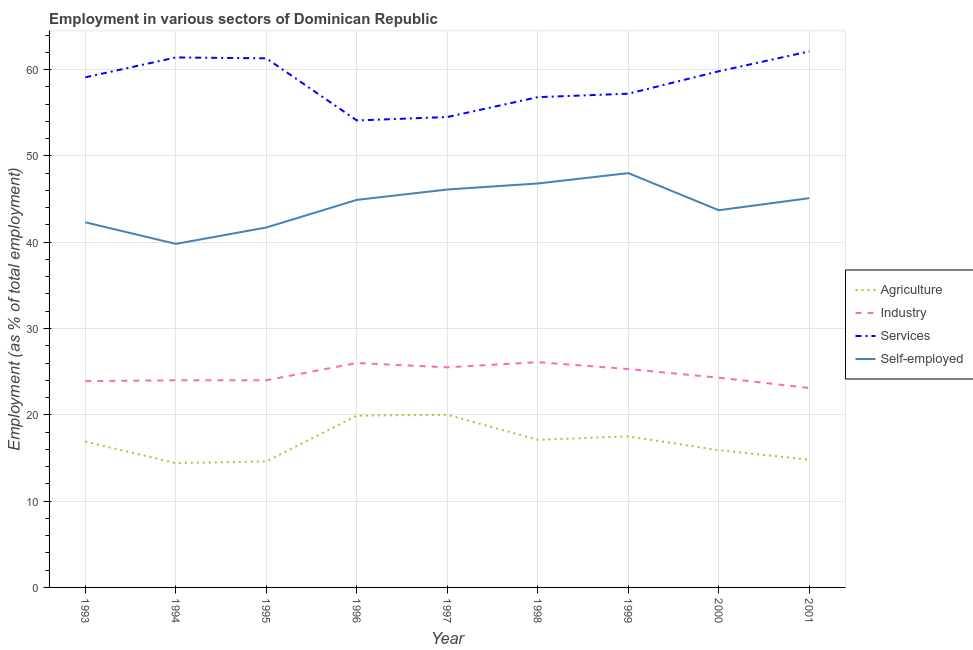Is the number of lines equal to the number of legend labels?
Your answer should be compact. Yes. What is the percentage of workers in services in 1998?
Offer a very short reply. 56.8. Across all years, what is the minimum percentage of workers in services?
Your answer should be very brief. 54.1. In which year was the percentage of workers in agriculture maximum?
Ensure brevity in your answer.  1997. What is the total percentage of workers in services in the graph?
Give a very brief answer. 526.3. What is the difference between the percentage of workers in services in 1994 and that in 2001?
Offer a very short reply. -0.7. What is the difference between the percentage of workers in industry in 2000 and the percentage of workers in services in 2001?
Keep it short and to the point. -37.8. What is the average percentage of workers in industry per year?
Offer a terse response. 24.69. In the year 1996, what is the difference between the percentage of workers in services and percentage of workers in industry?
Ensure brevity in your answer.  28.1. In how many years, is the percentage of workers in industry greater than 38 %?
Your answer should be very brief. 0. What is the ratio of the percentage of workers in agriculture in 1993 to that in 2001?
Provide a succinct answer. 1.14. Is the percentage of self employed workers in 1993 less than that in 1998?
Make the answer very short. Yes. Is the difference between the percentage of workers in services in 1993 and 1999 greater than the difference between the percentage of workers in agriculture in 1993 and 1999?
Ensure brevity in your answer.  Yes. What is the difference between the highest and the second highest percentage of workers in industry?
Keep it short and to the point. 0.1. What is the difference between the highest and the lowest percentage of self employed workers?
Offer a very short reply. 8.2. Is the sum of the percentage of workers in industry in 1998 and 1999 greater than the maximum percentage of self employed workers across all years?
Make the answer very short. Yes. Is it the case that in every year, the sum of the percentage of workers in agriculture and percentage of workers in industry is greater than the percentage of workers in services?
Make the answer very short. No. Is the percentage of workers in industry strictly less than the percentage of self employed workers over the years?
Make the answer very short. Yes. Are the values on the major ticks of Y-axis written in scientific E-notation?
Provide a succinct answer. No. Does the graph contain grids?
Keep it short and to the point. Yes. How many legend labels are there?
Offer a very short reply. 4. How are the legend labels stacked?
Your answer should be very brief. Vertical. What is the title of the graph?
Provide a short and direct response. Employment in various sectors of Dominican Republic. Does "Primary" appear as one of the legend labels in the graph?
Your response must be concise. No. What is the label or title of the Y-axis?
Provide a short and direct response. Employment (as % of total employment). What is the Employment (as % of total employment) of Agriculture in 1993?
Your answer should be very brief. 16.9. What is the Employment (as % of total employment) in Industry in 1993?
Give a very brief answer. 23.9. What is the Employment (as % of total employment) of Services in 1993?
Provide a succinct answer. 59.1. What is the Employment (as % of total employment) of Self-employed in 1993?
Keep it short and to the point. 42.3. What is the Employment (as % of total employment) of Agriculture in 1994?
Your answer should be very brief. 14.4. What is the Employment (as % of total employment) of Services in 1994?
Make the answer very short. 61.4. What is the Employment (as % of total employment) in Self-employed in 1994?
Give a very brief answer. 39.8. What is the Employment (as % of total employment) in Agriculture in 1995?
Offer a terse response. 14.6. What is the Employment (as % of total employment) of Industry in 1995?
Give a very brief answer. 24. What is the Employment (as % of total employment) in Services in 1995?
Your answer should be compact. 61.3. What is the Employment (as % of total employment) in Self-employed in 1995?
Offer a very short reply. 41.7. What is the Employment (as % of total employment) in Agriculture in 1996?
Make the answer very short. 19.9. What is the Employment (as % of total employment) of Services in 1996?
Provide a succinct answer. 54.1. What is the Employment (as % of total employment) of Self-employed in 1996?
Make the answer very short. 44.9. What is the Employment (as % of total employment) of Services in 1997?
Make the answer very short. 54.5. What is the Employment (as % of total employment) in Self-employed in 1997?
Provide a succinct answer. 46.1. What is the Employment (as % of total employment) of Agriculture in 1998?
Offer a very short reply. 17.1. What is the Employment (as % of total employment) in Industry in 1998?
Make the answer very short. 26.1. What is the Employment (as % of total employment) of Services in 1998?
Your answer should be very brief. 56.8. What is the Employment (as % of total employment) in Self-employed in 1998?
Offer a very short reply. 46.8. What is the Employment (as % of total employment) in Agriculture in 1999?
Your answer should be compact. 17.5. What is the Employment (as % of total employment) in Industry in 1999?
Offer a terse response. 25.3. What is the Employment (as % of total employment) in Services in 1999?
Your answer should be compact. 57.2. What is the Employment (as % of total employment) of Agriculture in 2000?
Keep it short and to the point. 15.9. What is the Employment (as % of total employment) of Industry in 2000?
Offer a terse response. 24.3. What is the Employment (as % of total employment) of Services in 2000?
Give a very brief answer. 59.8. What is the Employment (as % of total employment) in Self-employed in 2000?
Your answer should be compact. 43.7. What is the Employment (as % of total employment) of Agriculture in 2001?
Your answer should be compact. 14.8. What is the Employment (as % of total employment) of Industry in 2001?
Offer a very short reply. 23.1. What is the Employment (as % of total employment) of Services in 2001?
Provide a succinct answer. 62.1. What is the Employment (as % of total employment) in Self-employed in 2001?
Offer a terse response. 45.1. Across all years, what is the maximum Employment (as % of total employment) of Industry?
Keep it short and to the point. 26.1. Across all years, what is the maximum Employment (as % of total employment) in Services?
Offer a terse response. 62.1. Across all years, what is the minimum Employment (as % of total employment) of Agriculture?
Provide a short and direct response. 14.4. Across all years, what is the minimum Employment (as % of total employment) in Industry?
Give a very brief answer. 23.1. Across all years, what is the minimum Employment (as % of total employment) in Services?
Your answer should be compact. 54.1. Across all years, what is the minimum Employment (as % of total employment) of Self-employed?
Keep it short and to the point. 39.8. What is the total Employment (as % of total employment) in Agriculture in the graph?
Provide a short and direct response. 151.1. What is the total Employment (as % of total employment) of Industry in the graph?
Make the answer very short. 222.2. What is the total Employment (as % of total employment) in Services in the graph?
Offer a terse response. 526.3. What is the total Employment (as % of total employment) of Self-employed in the graph?
Give a very brief answer. 398.4. What is the difference between the Employment (as % of total employment) of Agriculture in 1993 and that in 1994?
Give a very brief answer. 2.5. What is the difference between the Employment (as % of total employment) of Agriculture in 1993 and that in 1995?
Provide a short and direct response. 2.3. What is the difference between the Employment (as % of total employment) of Industry in 1993 and that in 1995?
Keep it short and to the point. -0.1. What is the difference between the Employment (as % of total employment) in Agriculture in 1993 and that in 1996?
Your response must be concise. -3. What is the difference between the Employment (as % of total employment) in Industry in 1993 and that in 1996?
Keep it short and to the point. -2.1. What is the difference between the Employment (as % of total employment) of Agriculture in 1993 and that in 1997?
Give a very brief answer. -3.1. What is the difference between the Employment (as % of total employment) in Industry in 1993 and that in 1997?
Provide a succinct answer. -1.6. What is the difference between the Employment (as % of total employment) of Services in 1993 and that in 1997?
Keep it short and to the point. 4.6. What is the difference between the Employment (as % of total employment) in Industry in 1993 and that in 1998?
Keep it short and to the point. -2.2. What is the difference between the Employment (as % of total employment) of Self-employed in 1993 and that in 1998?
Offer a terse response. -4.5. What is the difference between the Employment (as % of total employment) in Agriculture in 1993 and that in 1999?
Ensure brevity in your answer.  -0.6. What is the difference between the Employment (as % of total employment) of Industry in 1993 and that in 1999?
Your answer should be very brief. -1.4. What is the difference between the Employment (as % of total employment) in Services in 1993 and that in 1999?
Ensure brevity in your answer.  1.9. What is the difference between the Employment (as % of total employment) of Agriculture in 1993 and that in 2001?
Provide a short and direct response. 2.1. What is the difference between the Employment (as % of total employment) of Agriculture in 1994 and that in 1995?
Provide a succinct answer. -0.2. What is the difference between the Employment (as % of total employment) in Industry in 1994 and that in 1995?
Offer a terse response. 0. What is the difference between the Employment (as % of total employment) in Self-employed in 1994 and that in 1995?
Your answer should be compact. -1.9. What is the difference between the Employment (as % of total employment) of Industry in 1994 and that in 1996?
Offer a very short reply. -2. What is the difference between the Employment (as % of total employment) in Services in 1994 and that in 1996?
Provide a succinct answer. 7.3. What is the difference between the Employment (as % of total employment) in Agriculture in 1994 and that in 1997?
Make the answer very short. -5.6. What is the difference between the Employment (as % of total employment) of Services in 1994 and that in 1997?
Give a very brief answer. 6.9. What is the difference between the Employment (as % of total employment) of Agriculture in 1994 and that in 1998?
Keep it short and to the point. -2.7. What is the difference between the Employment (as % of total employment) in Services in 1994 and that in 1998?
Offer a very short reply. 4.6. What is the difference between the Employment (as % of total employment) of Agriculture in 1994 and that in 1999?
Offer a terse response. -3.1. What is the difference between the Employment (as % of total employment) in Services in 1994 and that in 1999?
Offer a terse response. 4.2. What is the difference between the Employment (as % of total employment) in Self-employed in 1994 and that in 1999?
Your answer should be very brief. -8.2. What is the difference between the Employment (as % of total employment) in Agriculture in 1994 and that in 2000?
Ensure brevity in your answer.  -1.5. What is the difference between the Employment (as % of total employment) in Industry in 1994 and that in 2000?
Offer a terse response. -0.3. What is the difference between the Employment (as % of total employment) in Industry in 1994 and that in 2001?
Provide a short and direct response. 0.9. What is the difference between the Employment (as % of total employment) of Services in 1994 and that in 2001?
Provide a short and direct response. -0.7. What is the difference between the Employment (as % of total employment) in Industry in 1995 and that in 1996?
Make the answer very short. -2. What is the difference between the Employment (as % of total employment) in Agriculture in 1995 and that in 1998?
Provide a short and direct response. -2.5. What is the difference between the Employment (as % of total employment) of Self-employed in 1995 and that in 1998?
Give a very brief answer. -5.1. What is the difference between the Employment (as % of total employment) of Agriculture in 1995 and that in 1999?
Your answer should be very brief. -2.9. What is the difference between the Employment (as % of total employment) in Industry in 1995 and that in 1999?
Give a very brief answer. -1.3. What is the difference between the Employment (as % of total employment) of Services in 1995 and that in 1999?
Provide a succinct answer. 4.1. What is the difference between the Employment (as % of total employment) of Industry in 1995 and that in 2000?
Provide a succinct answer. -0.3. What is the difference between the Employment (as % of total employment) in Services in 1995 and that in 2000?
Your response must be concise. 1.5. What is the difference between the Employment (as % of total employment) of Self-employed in 1995 and that in 2000?
Your answer should be compact. -2. What is the difference between the Employment (as % of total employment) in Agriculture in 1995 and that in 2001?
Provide a short and direct response. -0.2. What is the difference between the Employment (as % of total employment) of Industry in 1995 and that in 2001?
Ensure brevity in your answer.  0.9. What is the difference between the Employment (as % of total employment) of Agriculture in 1996 and that in 1997?
Make the answer very short. -0.1. What is the difference between the Employment (as % of total employment) in Industry in 1996 and that in 1997?
Give a very brief answer. 0.5. What is the difference between the Employment (as % of total employment) in Agriculture in 1996 and that in 1998?
Offer a terse response. 2.8. What is the difference between the Employment (as % of total employment) of Industry in 1996 and that in 1998?
Make the answer very short. -0.1. What is the difference between the Employment (as % of total employment) of Agriculture in 1996 and that in 1999?
Offer a very short reply. 2.4. What is the difference between the Employment (as % of total employment) in Industry in 1996 and that in 1999?
Offer a very short reply. 0.7. What is the difference between the Employment (as % of total employment) of Agriculture in 1996 and that in 2000?
Your answer should be compact. 4. What is the difference between the Employment (as % of total employment) in Services in 1996 and that in 2000?
Make the answer very short. -5.7. What is the difference between the Employment (as % of total employment) in Services in 1997 and that in 1998?
Your response must be concise. -2.3. What is the difference between the Employment (as % of total employment) in Industry in 1997 and that in 1999?
Offer a very short reply. 0.2. What is the difference between the Employment (as % of total employment) in Services in 1997 and that in 1999?
Offer a very short reply. -2.7. What is the difference between the Employment (as % of total employment) in Self-employed in 1997 and that in 1999?
Your answer should be very brief. -1.9. What is the difference between the Employment (as % of total employment) of Agriculture in 1997 and that in 2000?
Make the answer very short. 4.1. What is the difference between the Employment (as % of total employment) of Agriculture in 1997 and that in 2001?
Ensure brevity in your answer.  5.2. What is the difference between the Employment (as % of total employment) in Services in 1997 and that in 2001?
Provide a succinct answer. -7.6. What is the difference between the Employment (as % of total employment) of Self-employed in 1997 and that in 2001?
Provide a succinct answer. 1. What is the difference between the Employment (as % of total employment) of Agriculture in 1998 and that in 1999?
Make the answer very short. -0.4. What is the difference between the Employment (as % of total employment) in Agriculture in 1998 and that in 2000?
Keep it short and to the point. 1.2. What is the difference between the Employment (as % of total employment) of Industry in 1998 and that in 2000?
Your response must be concise. 1.8. What is the difference between the Employment (as % of total employment) in Self-employed in 1998 and that in 2000?
Offer a terse response. 3.1. What is the difference between the Employment (as % of total employment) of Agriculture in 1998 and that in 2001?
Your answer should be very brief. 2.3. What is the difference between the Employment (as % of total employment) in Self-employed in 1999 and that in 2000?
Your answer should be very brief. 4.3. What is the difference between the Employment (as % of total employment) in Services in 1999 and that in 2001?
Offer a terse response. -4.9. What is the difference between the Employment (as % of total employment) in Industry in 2000 and that in 2001?
Offer a terse response. 1.2. What is the difference between the Employment (as % of total employment) of Self-employed in 2000 and that in 2001?
Offer a terse response. -1.4. What is the difference between the Employment (as % of total employment) of Agriculture in 1993 and the Employment (as % of total employment) of Services in 1994?
Offer a terse response. -44.5. What is the difference between the Employment (as % of total employment) in Agriculture in 1993 and the Employment (as % of total employment) in Self-employed in 1994?
Give a very brief answer. -22.9. What is the difference between the Employment (as % of total employment) of Industry in 1993 and the Employment (as % of total employment) of Services in 1994?
Offer a very short reply. -37.5. What is the difference between the Employment (as % of total employment) of Industry in 1993 and the Employment (as % of total employment) of Self-employed in 1994?
Your answer should be very brief. -15.9. What is the difference between the Employment (as % of total employment) of Services in 1993 and the Employment (as % of total employment) of Self-employed in 1994?
Make the answer very short. 19.3. What is the difference between the Employment (as % of total employment) of Agriculture in 1993 and the Employment (as % of total employment) of Industry in 1995?
Ensure brevity in your answer.  -7.1. What is the difference between the Employment (as % of total employment) of Agriculture in 1993 and the Employment (as % of total employment) of Services in 1995?
Your answer should be very brief. -44.4. What is the difference between the Employment (as % of total employment) in Agriculture in 1993 and the Employment (as % of total employment) in Self-employed in 1995?
Make the answer very short. -24.8. What is the difference between the Employment (as % of total employment) in Industry in 1993 and the Employment (as % of total employment) in Services in 1995?
Ensure brevity in your answer.  -37.4. What is the difference between the Employment (as % of total employment) in Industry in 1993 and the Employment (as % of total employment) in Self-employed in 1995?
Ensure brevity in your answer.  -17.8. What is the difference between the Employment (as % of total employment) in Agriculture in 1993 and the Employment (as % of total employment) in Services in 1996?
Your answer should be compact. -37.2. What is the difference between the Employment (as % of total employment) of Industry in 1993 and the Employment (as % of total employment) of Services in 1996?
Give a very brief answer. -30.2. What is the difference between the Employment (as % of total employment) in Services in 1993 and the Employment (as % of total employment) in Self-employed in 1996?
Ensure brevity in your answer.  14.2. What is the difference between the Employment (as % of total employment) of Agriculture in 1993 and the Employment (as % of total employment) of Industry in 1997?
Give a very brief answer. -8.6. What is the difference between the Employment (as % of total employment) of Agriculture in 1993 and the Employment (as % of total employment) of Services in 1997?
Provide a succinct answer. -37.6. What is the difference between the Employment (as % of total employment) of Agriculture in 1993 and the Employment (as % of total employment) of Self-employed in 1997?
Keep it short and to the point. -29.2. What is the difference between the Employment (as % of total employment) of Industry in 1993 and the Employment (as % of total employment) of Services in 1997?
Ensure brevity in your answer.  -30.6. What is the difference between the Employment (as % of total employment) of Industry in 1993 and the Employment (as % of total employment) of Self-employed in 1997?
Ensure brevity in your answer.  -22.2. What is the difference between the Employment (as % of total employment) in Services in 1993 and the Employment (as % of total employment) in Self-employed in 1997?
Provide a succinct answer. 13. What is the difference between the Employment (as % of total employment) in Agriculture in 1993 and the Employment (as % of total employment) in Services in 1998?
Offer a terse response. -39.9. What is the difference between the Employment (as % of total employment) in Agriculture in 1993 and the Employment (as % of total employment) in Self-employed in 1998?
Your response must be concise. -29.9. What is the difference between the Employment (as % of total employment) of Industry in 1993 and the Employment (as % of total employment) of Services in 1998?
Offer a terse response. -32.9. What is the difference between the Employment (as % of total employment) of Industry in 1993 and the Employment (as % of total employment) of Self-employed in 1998?
Your answer should be compact. -22.9. What is the difference between the Employment (as % of total employment) of Services in 1993 and the Employment (as % of total employment) of Self-employed in 1998?
Your answer should be compact. 12.3. What is the difference between the Employment (as % of total employment) in Agriculture in 1993 and the Employment (as % of total employment) in Services in 1999?
Keep it short and to the point. -40.3. What is the difference between the Employment (as % of total employment) in Agriculture in 1993 and the Employment (as % of total employment) in Self-employed in 1999?
Ensure brevity in your answer.  -31.1. What is the difference between the Employment (as % of total employment) of Industry in 1993 and the Employment (as % of total employment) of Services in 1999?
Ensure brevity in your answer.  -33.3. What is the difference between the Employment (as % of total employment) in Industry in 1993 and the Employment (as % of total employment) in Self-employed in 1999?
Provide a succinct answer. -24.1. What is the difference between the Employment (as % of total employment) of Services in 1993 and the Employment (as % of total employment) of Self-employed in 1999?
Offer a terse response. 11.1. What is the difference between the Employment (as % of total employment) of Agriculture in 1993 and the Employment (as % of total employment) of Industry in 2000?
Give a very brief answer. -7.4. What is the difference between the Employment (as % of total employment) in Agriculture in 1993 and the Employment (as % of total employment) in Services in 2000?
Your answer should be compact. -42.9. What is the difference between the Employment (as % of total employment) in Agriculture in 1993 and the Employment (as % of total employment) in Self-employed in 2000?
Ensure brevity in your answer.  -26.8. What is the difference between the Employment (as % of total employment) of Industry in 1993 and the Employment (as % of total employment) of Services in 2000?
Offer a terse response. -35.9. What is the difference between the Employment (as % of total employment) in Industry in 1993 and the Employment (as % of total employment) in Self-employed in 2000?
Give a very brief answer. -19.8. What is the difference between the Employment (as % of total employment) of Agriculture in 1993 and the Employment (as % of total employment) of Industry in 2001?
Offer a terse response. -6.2. What is the difference between the Employment (as % of total employment) of Agriculture in 1993 and the Employment (as % of total employment) of Services in 2001?
Ensure brevity in your answer.  -45.2. What is the difference between the Employment (as % of total employment) in Agriculture in 1993 and the Employment (as % of total employment) in Self-employed in 2001?
Offer a very short reply. -28.2. What is the difference between the Employment (as % of total employment) of Industry in 1993 and the Employment (as % of total employment) of Services in 2001?
Offer a terse response. -38.2. What is the difference between the Employment (as % of total employment) in Industry in 1993 and the Employment (as % of total employment) in Self-employed in 2001?
Offer a terse response. -21.2. What is the difference between the Employment (as % of total employment) of Services in 1993 and the Employment (as % of total employment) of Self-employed in 2001?
Provide a succinct answer. 14. What is the difference between the Employment (as % of total employment) in Agriculture in 1994 and the Employment (as % of total employment) in Services in 1995?
Make the answer very short. -46.9. What is the difference between the Employment (as % of total employment) of Agriculture in 1994 and the Employment (as % of total employment) of Self-employed in 1995?
Your answer should be compact. -27.3. What is the difference between the Employment (as % of total employment) of Industry in 1994 and the Employment (as % of total employment) of Services in 1995?
Offer a very short reply. -37.3. What is the difference between the Employment (as % of total employment) in Industry in 1994 and the Employment (as % of total employment) in Self-employed in 1995?
Ensure brevity in your answer.  -17.7. What is the difference between the Employment (as % of total employment) in Services in 1994 and the Employment (as % of total employment) in Self-employed in 1995?
Offer a very short reply. 19.7. What is the difference between the Employment (as % of total employment) in Agriculture in 1994 and the Employment (as % of total employment) in Industry in 1996?
Keep it short and to the point. -11.6. What is the difference between the Employment (as % of total employment) of Agriculture in 1994 and the Employment (as % of total employment) of Services in 1996?
Provide a succinct answer. -39.7. What is the difference between the Employment (as % of total employment) in Agriculture in 1994 and the Employment (as % of total employment) in Self-employed in 1996?
Give a very brief answer. -30.5. What is the difference between the Employment (as % of total employment) in Industry in 1994 and the Employment (as % of total employment) in Services in 1996?
Your answer should be very brief. -30.1. What is the difference between the Employment (as % of total employment) of Industry in 1994 and the Employment (as % of total employment) of Self-employed in 1996?
Offer a very short reply. -20.9. What is the difference between the Employment (as % of total employment) of Agriculture in 1994 and the Employment (as % of total employment) of Services in 1997?
Keep it short and to the point. -40.1. What is the difference between the Employment (as % of total employment) of Agriculture in 1994 and the Employment (as % of total employment) of Self-employed in 1997?
Provide a short and direct response. -31.7. What is the difference between the Employment (as % of total employment) of Industry in 1994 and the Employment (as % of total employment) of Services in 1997?
Ensure brevity in your answer.  -30.5. What is the difference between the Employment (as % of total employment) in Industry in 1994 and the Employment (as % of total employment) in Self-employed in 1997?
Ensure brevity in your answer.  -22.1. What is the difference between the Employment (as % of total employment) of Agriculture in 1994 and the Employment (as % of total employment) of Services in 1998?
Provide a succinct answer. -42.4. What is the difference between the Employment (as % of total employment) of Agriculture in 1994 and the Employment (as % of total employment) of Self-employed in 1998?
Your answer should be very brief. -32.4. What is the difference between the Employment (as % of total employment) in Industry in 1994 and the Employment (as % of total employment) in Services in 1998?
Ensure brevity in your answer.  -32.8. What is the difference between the Employment (as % of total employment) in Industry in 1994 and the Employment (as % of total employment) in Self-employed in 1998?
Provide a short and direct response. -22.8. What is the difference between the Employment (as % of total employment) in Services in 1994 and the Employment (as % of total employment) in Self-employed in 1998?
Make the answer very short. 14.6. What is the difference between the Employment (as % of total employment) of Agriculture in 1994 and the Employment (as % of total employment) of Industry in 1999?
Provide a short and direct response. -10.9. What is the difference between the Employment (as % of total employment) of Agriculture in 1994 and the Employment (as % of total employment) of Services in 1999?
Provide a succinct answer. -42.8. What is the difference between the Employment (as % of total employment) in Agriculture in 1994 and the Employment (as % of total employment) in Self-employed in 1999?
Ensure brevity in your answer.  -33.6. What is the difference between the Employment (as % of total employment) of Industry in 1994 and the Employment (as % of total employment) of Services in 1999?
Your answer should be very brief. -33.2. What is the difference between the Employment (as % of total employment) of Industry in 1994 and the Employment (as % of total employment) of Self-employed in 1999?
Your response must be concise. -24. What is the difference between the Employment (as % of total employment) in Services in 1994 and the Employment (as % of total employment) in Self-employed in 1999?
Give a very brief answer. 13.4. What is the difference between the Employment (as % of total employment) of Agriculture in 1994 and the Employment (as % of total employment) of Industry in 2000?
Offer a very short reply. -9.9. What is the difference between the Employment (as % of total employment) of Agriculture in 1994 and the Employment (as % of total employment) of Services in 2000?
Keep it short and to the point. -45.4. What is the difference between the Employment (as % of total employment) in Agriculture in 1994 and the Employment (as % of total employment) in Self-employed in 2000?
Provide a short and direct response. -29.3. What is the difference between the Employment (as % of total employment) in Industry in 1994 and the Employment (as % of total employment) in Services in 2000?
Keep it short and to the point. -35.8. What is the difference between the Employment (as % of total employment) in Industry in 1994 and the Employment (as % of total employment) in Self-employed in 2000?
Your answer should be very brief. -19.7. What is the difference between the Employment (as % of total employment) of Agriculture in 1994 and the Employment (as % of total employment) of Services in 2001?
Provide a short and direct response. -47.7. What is the difference between the Employment (as % of total employment) in Agriculture in 1994 and the Employment (as % of total employment) in Self-employed in 2001?
Your answer should be compact. -30.7. What is the difference between the Employment (as % of total employment) in Industry in 1994 and the Employment (as % of total employment) in Services in 2001?
Provide a succinct answer. -38.1. What is the difference between the Employment (as % of total employment) of Industry in 1994 and the Employment (as % of total employment) of Self-employed in 2001?
Your response must be concise. -21.1. What is the difference between the Employment (as % of total employment) of Agriculture in 1995 and the Employment (as % of total employment) of Services in 1996?
Offer a very short reply. -39.5. What is the difference between the Employment (as % of total employment) of Agriculture in 1995 and the Employment (as % of total employment) of Self-employed in 1996?
Your response must be concise. -30.3. What is the difference between the Employment (as % of total employment) in Industry in 1995 and the Employment (as % of total employment) in Services in 1996?
Ensure brevity in your answer.  -30.1. What is the difference between the Employment (as % of total employment) of Industry in 1995 and the Employment (as % of total employment) of Self-employed in 1996?
Offer a very short reply. -20.9. What is the difference between the Employment (as % of total employment) of Agriculture in 1995 and the Employment (as % of total employment) of Services in 1997?
Ensure brevity in your answer.  -39.9. What is the difference between the Employment (as % of total employment) of Agriculture in 1995 and the Employment (as % of total employment) of Self-employed in 1997?
Offer a very short reply. -31.5. What is the difference between the Employment (as % of total employment) of Industry in 1995 and the Employment (as % of total employment) of Services in 1997?
Provide a succinct answer. -30.5. What is the difference between the Employment (as % of total employment) in Industry in 1995 and the Employment (as % of total employment) in Self-employed in 1997?
Offer a very short reply. -22.1. What is the difference between the Employment (as % of total employment) in Services in 1995 and the Employment (as % of total employment) in Self-employed in 1997?
Give a very brief answer. 15.2. What is the difference between the Employment (as % of total employment) in Agriculture in 1995 and the Employment (as % of total employment) in Services in 1998?
Keep it short and to the point. -42.2. What is the difference between the Employment (as % of total employment) of Agriculture in 1995 and the Employment (as % of total employment) of Self-employed in 1998?
Offer a very short reply. -32.2. What is the difference between the Employment (as % of total employment) of Industry in 1995 and the Employment (as % of total employment) of Services in 1998?
Your response must be concise. -32.8. What is the difference between the Employment (as % of total employment) in Industry in 1995 and the Employment (as % of total employment) in Self-employed in 1998?
Make the answer very short. -22.8. What is the difference between the Employment (as % of total employment) of Services in 1995 and the Employment (as % of total employment) of Self-employed in 1998?
Your answer should be very brief. 14.5. What is the difference between the Employment (as % of total employment) in Agriculture in 1995 and the Employment (as % of total employment) in Industry in 1999?
Make the answer very short. -10.7. What is the difference between the Employment (as % of total employment) in Agriculture in 1995 and the Employment (as % of total employment) in Services in 1999?
Provide a short and direct response. -42.6. What is the difference between the Employment (as % of total employment) in Agriculture in 1995 and the Employment (as % of total employment) in Self-employed in 1999?
Provide a short and direct response. -33.4. What is the difference between the Employment (as % of total employment) of Industry in 1995 and the Employment (as % of total employment) of Services in 1999?
Your response must be concise. -33.2. What is the difference between the Employment (as % of total employment) in Industry in 1995 and the Employment (as % of total employment) in Self-employed in 1999?
Provide a short and direct response. -24. What is the difference between the Employment (as % of total employment) of Services in 1995 and the Employment (as % of total employment) of Self-employed in 1999?
Provide a succinct answer. 13.3. What is the difference between the Employment (as % of total employment) in Agriculture in 1995 and the Employment (as % of total employment) in Industry in 2000?
Give a very brief answer. -9.7. What is the difference between the Employment (as % of total employment) of Agriculture in 1995 and the Employment (as % of total employment) of Services in 2000?
Your answer should be very brief. -45.2. What is the difference between the Employment (as % of total employment) in Agriculture in 1995 and the Employment (as % of total employment) in Self-employed in 2000?
Keep it short and to the point. -29.1. What is the difference between the Employment (as % of total employment) of Industry in 1995 and the Employment (as % of total employment) of Services in 2000?
Provide a succinct answer. -35.8. What is the difference between the Employment (as % of total employment) in Industry in 1995 and the Employment (as % of total employment) in Self-employed in 2000?
Give a very brief answer. -19.7. What is the difference between the Employment (as % of total employment) in Agriculture in 1995 and the Employment (as % of total employment) in Services in 2001?
Provide a succinct answer. -47.5. What is the difference between the Employment (as % of total employment) in Agriculture in 1995 and the Employment (as % of total employment) in Self-employed in 2001?
Your answer should be very brief. -30.5. What is the difference between the Employment (as % of total employment) of Industry in 1995 and the Employment (as % of total employment) of Services in 2001?
Ensure brevity in your answer.  -38.1. What is the difference between the Employment (as % of total employment) in Industry in 1995 and the Employment (as % of total employment) in Self-employed in 2001?
Offer a terse response. -21.1. What is the difference between the Employment (as % of total employment) of Services in 1995 and the Employment (as % of total employment) of Self-employed in 2001?
Your answer should be compact. 16.2. What is the difference between the Employment (as % of total employment) in Agriculture in 1996 and the Employment (as % of total employment) in Services in 1997?
Your answer should be very brief. -34.6. What is the difference between the Employment (as % of total employment) in Agriculture in 1996 and the Employment (as % of total employment) in Self-employed in 1997?
Your answer should be very brief. -26.2. What is the difference between the Employment (as % of total employment) in Industry in 1996 and the Employment (as % of total employment) in Services in 1997?
Offer a very short reply. -28.5. What is the difference between the Employment (as % of total employment) of Industry in 1996 and the Employment (as % of total employment) of Self-employed in 1997?
Your answer should be compact. -20.1. What is the difference between the Employment (as % of total employment) of Agriculture in 1996 and the Employment (as % of total employment) of Services in 1998?
Make the answer very short. -36.9. What is the difference between the Employment (as % of total employment) in Agriculture in 1996 and the Employment (as % of total employment) in Self-employed in 1998?
Your answer should be very brief. -26.9. What is the difference between the Employment (as % of total employment) of Industry in 1996 and the Employment (as % of total employment) of Services in 1998?
Make the answer very short. -30.8. What is the difference between the Employment (as % of total employment) of Industry in 1996 and the Employment (as % of total employment) of Self-employed in 1998?
Offer a very short reply. -20.8. What is the difference between the Employment (as % of total employment) in Agriculture in 1996 and the Employment (as % of total employment) in Industry in 1999?
Your answer should be compact. -5.4. What is the difference between the Employment (as % of total employment) in Agriculture in 1996 and the Employment (as % of total employment) in Services in 1999?
Provide a succinct answer. -37.3. What is the difference between the Employment (as % of total employment) in Agriculture in 1996 and the Employment (as % of total employment) in Self-employed in 1999?
Give a very brief answer. -28.1. What is the difference between the Employment (as % of total employment) of Industry in 1996 and the Employment (as % of total employment) of Services in 1999?
Keep it short and to the point. -31.2. What is the difference between the Employment (as % of total employment) in Agriculture in 1996 and the Employment (as % of total employment) in Industry in 2000?
Give a very brief answer. -4.4. What is the difference between the Employment (as % of total employment) of Agriculture in 1996 and the Employment (as % of total employment) of Services in 2000?
Your response must be concise. -39.9. What is the difference between the Employment (as % of total employment) in Agriculture in 1996 and the Employment (as % of total employment) in Self-employed in 2000?
Your response must be concise. -23.8. What is the difference between the Employment (as % of total employment) of Industry in 1996 and the Employment (as % of total employment) of Services in 2000?
Offer a very short reply. -33.8. What is the difference between the Employment (as % of total employment) of Industry in 1996 and the Employment (as % of total employment) of Self-employed in 2000?
Your response must be concise. -17.7. What is the difference between the Employment (as % of total employment) in Agriculture in 1996 and the Employment (as % of total employment) in Industry in 2001?
Make the answer very short. -3.2. What is the difference between the Employment (as % of total employment) of Agriculture in 1996 and the Employment (as % of total employment) of Services in 2001?
Provide a succinct answer. -42.2. What is the difference between the Employment (as % of total employment) of Agriculture in 1996 and the Employment (as % of total employment) of Self-employed in 2001?
Give a very brief answer. -25.2. What is the difference between the Employment (as % of total employment) of Industry in 1996 and the Employment (as % of total employment) of Services in 2001?
Keep it short and to the point. -36.1. What is the difference between the Employment (as % of total employment) in Industry in 1996 and the Employment (as % of total employment) in Self-employed in 2001?
Keep it short and to the point. -19.1. What is the difference between the Employment (as % of total employment) of Services in 1996 and the Employment (as % of total employment) of Self-employed in 2001?
Make the answer very short. 9. What is the difference between the Employment (as % of total employment) of Agriculture in 1997 and the Employment (as % of total employment) of Services in 1998?
Your response must be concise. -36.8. What is the difference between the Employment (as % of total employment) of Agriculture in 1997 and the Employment (as % of total employment) of Self-employed in 1998?
Provide a short and direct response. -26.8. What is the difference between the Employment (as % of total employment) in Industry in 1997 and the Employment (as % of total employment) in Services in 1998?
Keep it short and to the point. -31.3. What is the difference between the Employment (as % of total employment) in Industry in 1997 and the Employment (as % of total employment) in Self-employed in 1998?
Make the answer very short. -21.3. What is the difference between the Employment (as % of total employment) of Agriculture in 1997 and the Employment (as % of total employment) of Industry in 1999?
Offer a terse response. -5.3. What is the difference between the Employment (as % of total employment) of Agriculture in 1997 and the Employment (as % of total employment) of Services in 1999?
Your answer should be compact. -37.2. What is the difference between the Employment (as % of total employment) in Industry in 1997 and the Employment (as % of total employment) in Services in 1999?
Provide a succinct answer. -31.7. What is the difference between the Employment (as % of total employment) in Industry in 1997 and the Employment (as % of total employment) in Self-employed in 1999?
Provide a short and direct response. -22.5. What is the difference between the Employment (as % of total employment) in Services in 1997 and the Employment (as % of total employment) in Self-employed in 1999?
Provide a short and direct response. 6.5. What is the difference between the Employment (as % of total employment) in Agriculture in 1997 and the Employment (as % of total employment) in Industry in 2000?
Keep it short and to the point. -4.3. What is the difference between the Employment (as % of total employment) of Agriculture in 1997 and the Employment (as % of total employment) of Services in 2000?
Your response must be concise. -39.8. What is the difference between the Employment (as % of total employment) of Agriculture in 1997 and the Employment (as % of total employment) of Self-employed in 2000?
Give a very brief answer. -23.7. What is the difference between the Employment (as % of total employment) in Industry in 1997 and the Employment (as % of total employment) in Services in 2000?
Provide a short and direct response. -34.3. What is the difference between the Employment (as % of total employment) of Industry in 1997 and the Employment (as % of total employment) of Self-employed in 2000?
Your response must be concise. -18.2. What is the difference between the Employment (as % of total employment) in Agriculture in 1997 and the Employment (as % of total employment) in Services in 2001?
Offer a terse response. -42.1. What is the difference between the Employment (as % of total employment) of Agriculture in 1997 and the Employment (as % of total employment) of Self-employed in 2001?
Provide a short and direct response. -25.1. What is the difference between the Employment (as % of total employment) of Industry in 1997 and the Employment (as % of total employment) of Services in 2001?
Offer a terse response. -36.6. What is the difference between the Employment (as % of total employment) of Industry in 1997 and the Employment (as % of total employment) of Self-employed in 2001?
Offer a terse response. -19.6. What is the difference between the Employment (as % of total employment) of Agriculture in 1998 and the Employment (as % of total employment) of Services in 1999?
Your answer should be very brief. -40.1. What is the difference between the Employment (as % of total employment) in Agriculture in 1998 and the Employment (as % of total employment) in Self-employed in 1999?
Keep it short and to the point. -30.9. What is the difference between the Employment (as % of total employment) of Industry in 1998 and the Employment (as % of total employment) of Services in 1999?
Offer a very short reply. -31.1. What is the difference between the Employment (as % of total employment) in Industry in 1998 and the Employment (as % of total employment) in Self-employed in 1999?
Provide a succinct answer. -21.9. What is the difference between the Employment (as % of total employment) in Agriculture in 1998 and the Employment (as % of total employment) in Industry in 2000?
Keep it short and to the point. -7.2. What is the difference between the Employment (as % of total employment) in Agriculture in 1998 and the Employment (as % of total employment) in Services in 2000?
Make the answer very short. -42.7. What is the difference between the Employment (as % of total employment) of Agriculture in 1998 and the Employment (as % of total employment) of Self-employed in 2000?
Your response must be concise. -26.6. What is the difference between the Employment (as % of total employment) of Industry in 1998 and the Employment (as % of total employment) of Services in 2000?
Provide a short and direct response. -33.7. What is the difference between the Employment (as % of total employment) of Industry in 1998 and the Employment (as % of total employment) of Self-employed in 2000?
Your answer should be compact. -17.6. What is the difference between the Employment (as % of total employment) in Services in 1998 and the Employment (as % of total employment) in Self-employed in 2000?
Make the answer very short. 13.1. What is the difference between the Employment (as % of total employment) of Agriculture in 1998 and the Employment (as % of total employment) of Industry in 2001?
Your answer should be compact. -6. What is the difference between the Employment (as % of total employment) of Agriculture in 1998 and the Employment (as % of total employment) of Services in 2001?
Provide a short and direct response. -45. What is the difference between the Employment (as % of total employment) of Agriculture in 1998 and the Employment (as % of total employment) of Self-employed in 2001?
Your answer should be compact. -28. What is the difference between the Employment (as % of total employment) in Industry in 1998 and the Employment (as % of total employment) in Services in 2001?
Your response must be concise. -36. What is the difference between the Employment (as % of total employment) in Industry in 1998 and the Employment (as % of total employment) in Self-employed in 2001?
Provide a succinct answer. -19. What is the difference between the Employment (as % of total employment) in Agriculture in 1999 and the Employment (as % of total employment) in Services in 2000?
Provide a short and direct response. -42.3. What is the difference between the Employment (as % of total employment) in Agriculture in 1999 and the Employment (as % of total employment) in Self-employed in 2000?
Provide a succinct answer. -26.2. What is the difference between the Employment (as % of total employment) of Industry in 1999 and the Employment (as % of total employment) of Services in 2000?
Keep it short and to the point. -34.5. What is the difference between the Employment (as % of total employment) in Industry in 1999 and the Employment (as % of total employment) in Self-employed in 2000?
Keep it short and to the point. -18.4. What is the difference between the Employment (as % of total employment) in Agriculture in 1999 and the Employment (as % of total employment) in Services in 2001?
Keep it short and to the point. -44.6. What is the difference between the Employment (as % of total employment) in Agriculture in 1999 and the Employment (as % of total employment) in Self-employed in 2001?
Your response must be concise. -27.6. What is the difference between the Employment (as % of total employment) in Industry in 1999 and the Employment (as % of total employment) in Services in 2001?
Give a very brief answer. -36.8. What is the difference between the Employment (as % of total employment) in Industry in 1999 and the Employment (as % of total employment) in Self-employed in 2001?
Provide a short and direct response. -19.8. What is the difference between the Employment (as % of total employment) in Agriculture in 2000 and the Employment (as % of total employment) in Services in 2001?
Give a very brief answer. -46.2. What is the difference between the Employment (as % of total employment) of Agriculture in 2000 and the Employment (as % of total employment) of Self-employed in 2001?
Your answer should be very brief. -29.2. What is the difference between the Employment (as % of total employment) of Industry in 2000 and the Employment (as % of total employment) of Services in 2001?
Provide a short and direct response. -37.8. What is the difference between the Employment (as % of total employment) in Industry in 2000 and the Employment (as % of total employment) in Self-employed in 2001?
Ensure brevity in your answer.  -20.8. What is the average Employment (as % of total employment) of Agriculture per year?
Provide a short and direct response. 16.79. What is the average Employment (as % of total employment) in Industry per year?
Offer a very short reply. 24.69. What is the average Employment (as % of total employment) in Services per year?
Your answer should be very brief. 58.48. What is the average Employment (as % of total employment) in Self-employed per year?
Your response must be concise. 44.27. In the year 1993, what is the difference between the Employment (as % of total employment) of Agriculture and Employment (as % of total employment) of Services?
Ensure brevity in your answer.  -42.2. In the year 1993, what is the difference between the Employment (as % of total employment) in Agriculture and Employment (as % of total employment) in Self-employed?
Offer a terse response. -25.4. In the year 1993, what is the difference between the Employment (as % of total employment) in Industry and Employment (as % of total employment) in Services?
Your answer should be very brief. -35.2. In the year 1993, what is the difference between the Employment (as % of total employment) in Industry and Employment (as % of total employment) in Self-employed?
Provide a short and direct response. -18.4. In the year 1994, what is the difference between the Employment (as % of total employment) in Agriculture and Employment (as % of total employment) in Services?
Offer a very short reply. -47. In the year 1994, what is the difference between the Employment (as % of total employment) in Agriculture and Employment (as % of total employment) in Self-employed?
Give a very brief answer. -25.4. In the year 1994, what is the difference between the Employment (as % of total employment) in Industry and Employment (as % of total employment) in Services?
Your answer should be compact. -37.4. In the year 1994, what is the difference between the Employment (as % of total employment) of Industry and Employment (as % of total employment) of Self-employed?
Offer a very short reply. -15.8. In the year 1994, what is the difference between the Employment (as % of total employment) in Services and Employment (as % of total employment) in Self-employed?
Keep it short and to the point. 21.6. In the year 1995, what is the difference between the Employment (as % of total employment) in Agriculture and Employment (as % of total employment) in Services?
Make the answer very short. -46.7. In the year 1995, what is the difference between the Employment (as % of total employment) of Agriculture and Employment (as % of total employment) of Self-employed?
Your answer should be very brief. -27.1. In the year 1995, what is the difference between the Employment (as % of total employment) of Industry and Employment (as % of total employment) of Services?
Your answer should be very brief. -37.3. In the year 1995, what is the difference between the Employment (as % of total employment) of Industry and Employment (as % of total employment) of Self-employed?
Give a very brief answer. -17.7. In the year 1995, what is the difference between the Employment (as % of total employment) of Services and Employment (as % of total employment) of Self-employed?
Your answer should be very brief. 19.6. In the year 1996, what is the difference between the Employment (as % of total employment) of Agriculture and Employment (as % of total employment) of Industry?
Your answer should be compact. -6.1. In the year 1996, what is the difference between the Employment (as % of total employment) in Agriculture and Employment (as % of total employment) in Services?
Your response must be concise. -34.2. In the year 1996, what is the difference between the Employment (as % of total employment) in Agriculture and Employment (as % of total employment) in Self-employed?
Keep it short and to the point. -25. In the year 1996, what is the difference between the Employment (as % of total employment) of Industry and Employment (as % of total employment) of Services?
Keep it short and to the point. -28.1. In the year 1996, what is the difference between the Employment (as % of total employment) of Industry and Employment (as % of total employment) of Self-employed?
Your response must be concise. -18.9. In the year 1997, what is the difference between the Employment (as % of total employment) of Agriculture and Employment (as % of total employment) of Industry?
Your answer should be compact. -5.5. In the year 1997, what is the difference between the Employment (as % of total employment) in Agriculture and Employment (as % of total employment) in Services?
Your answer should be very brief. -34.5. In the year 1997, what is the difference between the Employment (as % of total employment) in Agriculture and Employment (as % of total employment) in Self-employed?
Keep it short and to the point. -26.1. In the year 1997, what is the difference between the Employment (as % of total employment) in Industry and Employment (as % of total employment) in Self-employed?
Offer a very short reply. -20.6. In the year 1998, what is the difference between the Employment (as % of total employment) of Agriculture and Employment (as % of total employment) of Industry?
Your answer should be compact. -9. In the year 1998, what is the difference between the Employment (as % of total employment) in Agriculture and Employment (as % of total employment) in Services?
Provide a succinct answer. -39.7. In the year 1998, what is the difference between the Employment (as % of total employment) of Agriculture and Employment (as % of total employment) of Self-employed?
Your answer should be very brief. -29.7. In the year 1998, what is the difference between the Employment (as % of total employment) of Industry and Employment (as % of total employment) of Services?
Make the answer very short. -30.7. In the year 1998, what is the difference between the Employment (as % of total employment) of Industry and Employment (as % of total employment) of Self-employed?
Your answer should be compact. -20.7. In the year 1998, what is the difference between the Employment (as % of total employment) in Services and Employment (as % of total employment) in Self-employed?
Give a very brief answer. 10. In the year 1999, what is the difference between the Employment (as % of total employment) of Agriculture and Employment (as % of total employment) of Industry?
Keep it short and to the point. -7.8. In the year 1999, what is the difference between the Employment (as % of total employment) in Agriculture and Employment (as % of total employment) in Services?
Offer a terse response. -39.7. In the year 1999, what is the difference between the Employment (as % of total employment) of Agriculture and Employment (as % of total employment) of Self-employed?
Your answer should be compact. -30.5. In the year 1999, what is the difference between the Employment (as % of total employment) in Industry and Employment (as % of total employment) in Services?
Offer a terse response. -31.9. In the year 1999, what is the difference between the Employment (as % of total employment) in Industry and Employment (as % of total employment) in Self-employed?
Provide a short and direct response. -22.7. In the year 1999, what is the difference between the Employment (as % of total employment) of Services and Employment (as % of total employment) of Self-employed?
Provide a short and direct response. 9.2. In the year 2000, what is the difference between the Employment (as % of total employment) of Agriculture and Employment (as % of total employment) of Services?
Give a very brief answer. -43.9. In the year 2000, what is the difference between the Employment (as % of total employment) in Agriculture and Employment (as % of total employment) in Self-employed?
Your answer should be compact. -27.8. In the year 2000, what is the difference between the Employment (as % of total employment) in Industry and Employment (as % of total employment) in Services?
Provide a succinct answer. -35.5. In the year 2000, what is the difference between the Employment (as % of total employment) in Industry and Employment (as % of total employment) in Self-employed?
Offer a very short reply. -19.4. In the year 2000, what is the difference between the Employment (as % of total employment) in Services and Employment (as % of total employment) in Self-employed?
Provide a succinct answer. 16.1. In the year 2001, what is the difference between the Employment (as % of total employment) of Agriculture and Employment (as % of total employment) of Industry?
Provide a succinct answer. -8.3. In the year 2001, what is the difference between the Employment (as % of total employment) of Agriculture and Employment (as % of total employment) of Services?
Your answer should be compact. -47.3. In the year 2001, what is the difference between the Employment (as % of total employment) of Agriculture and Employment (as % of total employment) of Self-employed?
Offer a terse response. -30.3. In the year 2001, what is the difference between the Employment (as % of total employment) in Industry and Employment (as % of total employment) in Services?
Offer a terse response. -39. What is the ratio of the Employment (as % of total employment) in Agriculture in 1993 to that in 1994?
Provide a succinct answer. 1.17. What is the ratio of the Employment (as % of total employment) of Industry in 1993 to that in 1994?
Keep it short and to the point. 1. What is the ratio of the Employment (as % of total employment) of Services in 1993 to that in 1994?
Ensure brevity in your answer.  0.96. What is the ratio of the Employment (as % of total employment) in Self-employed in 1993 to that in 1994?
Keep it short and to the point. 1.06. What is the ratio of the Employment (as % of total employment) in Agriculture in 1993 to that in 1995?
Make the answer very short. 1.16. What is the ratio of the Employment (as % of total employment) of Industry in 1993 to that in 1995?
Keep it short and to the point. 1. What is the ratio of the Employment (as % of total employment) in Services in 1993 to that in 1995?
Provide a short and direct response. 0.96. What is the ratio of the Employment (as % of total employment) of Self-employed in 1993 to that in 1995?
Your response must be concise. 1.01. What is the ratio of the Employment (as % of total employment) of Agriculture in 1993 to that in 1996?
Provide a short and direct response. 0.85. What is the ratio of the Employment (as % of total employment) in Industry in 1993 to that in 1996?
Give a very brief answer. 0.92. What is the ratio of the Employment (as % of total employment) of Services in 1993 to that in 1996?
Make the answer very short. 1.09. What is the ratio of the Employment (as % of total employment) of Self-employed in 1993 to that in 1996?
Ensure brevity in your answer.  0.94. What is the ratio of the Employment (as % of total employment) in Agriculture in 1993 to that in 1997?
Provide a short and direct response. 0.84. What is the ratio of the Employment (as % of total employment) of Industry in 1993 to that in 1997?
Provide a short and direct response. 0.94. What is the ratio of the Employment (as % of total employment) of Services in 1993 to that in 1997?
Keep it short and to the point. 1.08. What is the ratio of the Employment (as % of total employment) of Self-employed in 1993 to that in 1997?
Your answer should be very brief. 0.92. What is the ratio of the Employment (as % of total employment) in Agriculture in 1993 to that in 1998?
Offer a very short reply. 0.99. What is the ratio of the Employment (as % of total employment) in Industry in 1993 to that in 1998?
Your answer should be very brief. 0.92. What is the ratio of the Employment (as % of total employment) in Services in 1993 to that in 1998?
Your response must be concise. 1.04. What is the ratio of the Employment (as % of total employment) in Self-employed in 1993 to that in 1998?
Your answer should be compact. 0.9. What is the ratio of the Employment (as % of total employment) of Agriculture in 1993 to that in 1999?
Provide a succinct answer. 0.97. What is the ratio of the Employment (as % of total employment) of Industry in 1993 to that in 1999?
Your answer should be very brief. 0.94. What is the ratio of the Employment (as % of total employment) in Services in 1993 to that in 1999?
Keep it short and to the point. 1.03. What is the ratio of the Employment (as % of total employment) of Self-employed in 1993 to that in 1999?
Ensure brevity in your answer.  0.88. What is the ratio of the Employment (as % of total employment) in Agriculture in 1993 to that in 2000?
Ensure brevity in your answer.  1.06. What is the ratio of the Employment (as % of total employment) in Industry in 1993 to that in 2000?
Your answer should be compact. 0.98. What is the ratio of the Employment (as % of total employment) in Services in 1993 to that in 2000?
Ensure brevity in your answer.  0.99. What is the ratio of the Employment (as % of total employment) in Agriculture in 1993 to that in 2001?
Your response must be concise. 1.14. What is the ratio of the Employment (as % of total employment) in Industry in 1993 to that in 2001?
Keep it short and to the point. 1.03. What is the ratio of the Employment (as % of total employment) in Services in 1993 to that in 2001?
Give a very brief answer. 0.95. What is the ratio of the Employment (as % of total employment) of Self-employed in 1993 to that in 2001?
Give a very brief answer. 0.94. What is the ratio of the Employment (as % of total employment) of Agriculture in 1994 to that in 1995?
Offer a very short reply. 0.99. What is the ratio of the Employment (as % of total employment) of Self-employed in 1994 to that in 1995?
Your answer should be compact. 0.95. What is the ratio of the Employment (as % of total employment) of Agriculture in 1994 to that in 1996?
Give a very brief answer. 0.72. What is the ratio of the Employment (as % of total employment) in Industry in 1994 to that in 1996?
Make the answer very short. 0.92. What is the ratio of the Employment (as % of total employment) in Services in 1994 to that in 1996?
Offer a very short reply. 1.13. What is the ratio of the Employment (as % of total employment) in Self-employed in 1994 to that in 1996?
Your answer should be compact. 0.89. What is the ratio of the Employment (as % of total employment) of Agriculture in 1994 to that in 1997?
Your answer should be compact. 0.72. What is the ratio of the Employment (as % of total employment) in Services in 1994 to that in 1997?
Offer a very short reply. 1.13. What is the ratio of the Employment (as % of total employment) of Self-employed in 1994 to that in 1997?
Make the answer very short. 0.86. What is the ratio of the Employment (as % of total employment) of Agriculture in 1994 to that in 1998?
Keep it short and to the point. 0.84. What is the ratio of the Employment (as % of total employment) of Industry in 1994 to that in 1998?
Make the answer very short. 0.92. What is the ratio of the Employment (as % of total employment) in Services in 1994 to that in 1998?
Ensure brevity in your answer.  1.08. What is the ratio of the Employment (as % of total employment) in Self-employed in 1994 to that in 1998?
Keep it short and to the point. 0.85. What is the ratio of the Employment (as % of total employment) in Agriculture in 1994 to that in 1999?
Give a very brief answer. 0.82. What is the ratio of the Employment (as % of total employment) of Industry in 1994 to that in 1999?
Offer a very short reply. 0.95. What is the ratio of the Employment (as % of total employment) in Services in 1994 to that in 1999?
Give a very brief answer. 1.07. What is the ratio of the Employment (as % of total employment) of Self-employed in 1994 to that in 1999?
Ensure brevity in your answer.  0.83. What is the ratio of the Employment (as % of total employment) in Agriculture in 1994 to that in 2000?
Offer a terse response. 0.91. What is the ratio of the Employment (as % of total employment) of Industry in 1994 to that in 2000?
Provide a short and direct response. 0.99. What is the ratio of the Employment (as % of total employment) of Services in 1994 to that in 2000?
Provide a short and direct response. 1.03. What is the ratio of the Employment (as % of total employment) of Self-employed in 1994 to that in 2000?
Your answer should be very brief. 0.91. What is the ratio of the Employment (as % of total employment) of Industry in 1994 to that in 2001?
Give a very brief answer. 1.04. What is the ratio of the Employment (as % of total employment) of Services in 1994 to that in 2001?
Make the answer very short. 0.99. What is the ratio of the Employment (as % of total employment) in Self-employed in 1994 to that in 2001?
Give a very brief answer. 0.88. What is the ratio of the Employment (as % of total employment) of Agriculture in 1995 to that in 1996?
Offer a terse response. 0.73. What is the ratio of the Employment (as % of total employment) in Services in 1995 to that in 1996?
Your response must be concise. 1.13. What is the ratio of the Employment (as % of total employment) in Self-employed in 1995 to that in 1996?
Your answer should be very brief. 0.93. What is the ratio of the Employment (as % of total employment) of Agriculture in 1995 to that in 1997?
Your answer should be compact. 0.73. What is the ratio of the Employment (as % of total employment) of Industry in 1995 to that in 1997?
Provide a succinct answer. 0.94. What is the ratio of the Employment (as % of total employment) of Services in 1995 to that in 1997?
Ensure brevity in your answer.  1.12. What is the ratio of the Employment (as % of total employment) in Self-employed in 1995 to that in 1997?
Offer a terse response. 0.9. What is the ratio of the Employment (as % of total employment) in Agriculture in 1995 to that in 1998?
Your response must be concise. 0.85. What is the ratio of the Employment (as % of total employment) in Industry in 1995 to that in 1998?
Offer a very short reply. 0.92. What is the ratio of the Employment (as % of total employment) of Services in 1995 to that in 1998?
Provide a succinct answer. 1.08. What is the ratio of the Employment (as % of total employment) in Self-employed in 1995 to that in 1998?
Provide a short and direct response. 0.89. What is the ratio of the Employment (as % of total employment) of Agriculture in 1995 to that in 1999?
Offer a terse response. 0.83. What is the ratio of the Employment (as % of total employment) in Industry in 1995 to that in 1999?
Provide a short and direct response. 0.95. What is the ratio of the Employment (as % of total employment) of Services in 1995 to that in 1999?
Provide a succinct answer. 1.07. What is the ratio of the Employment (as % of total employment) in Self-employed in 1995 to that in 1999?
Ensure brevity in your answer.  0.87. What is the ratio of the Employment (as % of total employment) of Agriculture in 1995 to that in 2000?
Your response must be concise. 0.92. What is the ratio of the Employment (as % of total employment) of Industry in 1995 to that in 2000?
Keep it short and to the point. 0.99. What is the ratio of the Employment (as % of total employment) in Services in 1995 to that in 2000?
Ensure brevity in your answer.  1.03. What is the ratio of the Employment (as % of total employment) of Self-employed in 1995 to that in 2000?
Your answer should be very brief. 0.95. What is the ratio of the Employment (as % of total employment) in Agriculture in 1995 to that in 2001?
Keep it short and to the point. 0.99. What is the ratio of the Employment (as % of total employment) of Industry in 1995 to that in 2001?
Provide a succinct answer. 1.04. What is the ratio of the Employment (as % of total employment) in Services in 1995 to that in 2001?
Provide a short and direct response. 0.99. What is the ratio of the Employment (as % of total employment) in Self-employed in 1995 to that in 2001?
Your answer should be very brief. 0.92. What is the ratio of the Employment (as % of total employment) of Agriculture in 1996 to that in 1997?
Your response must be concise. 0.99. What is the ratio of the Employment (as % of total employment) in Industry in 1996 to that in 1997?
Provide a short and direct response. 1.02. What is the ratio of the Employment (as % of total employment) of Self-employed in 1996 to that in 1997?
Your response must be concise. 0.97. What is the ratio of the Employment (as % of total employment) in Agriculture in 1996 to that in 1998?
Make the answer very short. 1.16. What is the ratio of the Employment (as % of total employment) of Industry in 1996 to that in 1998?
Your answer should be very brief. 1. What is the ratio of the Employment (as % of total employment) in Services in 1996 to that in 1998?
Ensure brevity in your answer.  0.95. What is the ratio of the Employment (as % of total employment) in Self-employed in 1996 to that in 1998?
Provide a succinct answer. 0.96. What is the ratio of the Employment (as % of total employment) in Agriculture in 1996 to that in 1999?
Provide a succinct answer. 1.14. What is the ratio of the Employment (as % of total employment) in Industry in 1996 to that in 1999?
Ensure brevity in your answer.  1.03. What is the ratio of the Employment (as % of total employment) of Services in 1996 to that in 1999?
Ensure brevity in your answer.  0.95. What is the ratio of the Employment (as % of total employment) of Self-employed in 1996 to that in 1999?
Give a very brief answer. 0.94. What is the ratio of the Employment (as % of total employment) in Agriculture in 1996 to that in 2000?
Provide a succinct answer. 1.25. What is the ratio of the Employment (as % of total employment) in Industry in 1996 to that in 2000?
Provide a short and direct response. 1.07. What is the ratio of the Employment (as % of total employment) of Services in 1996 to that in 2000?
Provide a short and direct response. 0.9. What is the ratio of the Employment (as % of total employment) in Self-employed in 1996 to that in 2000?
Your response must be concise. 1.03. What is the ratio of the Employment (as % of total employment) in Agriculture in 1996 to that in 2001?
Your answer should be very brief. 1.34. What is the ratio of the Employment (as % of total employment) of Industry in 1996 to that in 2001?
Provide a short and direct response. 1.13. What is the ratio of the Employment (as % of total employment) of Services in 1996 to that in 2001?
Provide a short and direct response. 0.87. What is the ratio of the Employment (as % of total employment) of Agriculture in 1997 to that in 1998?
Offer a terse response. 1.17. What is the ratio of the Employment (as % of total employment) in Industry in 1997 to that in 1998?
Your answer should be very brief. 0.98. What is the ratio of the Employment (as % of total employment) in Services in 1997 to that in 1998?
Keep it short and to the point. 0.96. What is the ratio of the Employment (as % of total employment) in Industry in 1997 to that in 1999?
Your answer should be compact. 1.01. What is the ratio of the Employment (as % of total employment) of Services in 1997 to that in 1999?
Offer a very short reply. 0.95. What is the ratio of the Employment (as % of total employment) in Self-employed in 1997 to that in 1999?
Give a very brief answer. 0.96. What is the ratio of the Employment (as % of total employment) of Agriculture in 1997 to that in 2000?
Make the answer very short. 1.26. What is the ratio of the Employment (as % of total employment) of Industry in 1997 to that in 2000?
Your response must be concise. 1.05. What is the ratio of the Employment (as % of total employment) of Services in 1997 to that in 2000?
Make the answer very short. 0.91. What is the ratio of the Employment (as % of total employment) in Self-employed in 1997 to that in 2000?
Provide a short and direct response. 1.05. What is the ratio of the Employment (as % of total employment) in Agriculture in 1997 to that in 2001?
Make the answer very short. 1.35. What is the ratio of the Employment (as % of total employment) in Industry in 1997 to that in 2001?
Make the answer very short. 1.1. What is the ratio of the Employment (as % of total employment) in Services in 1997 to that in 2001?
Provide a short and direct response. 0.88. What is the ratio of the Employment (as % of total employment) of Self-employed in 1997 to that in 2001?
Make the answer very short. 1.02. What is the ratio of the Employment (as % of total employment) in Agriculture in 1998 to that in 1999?
Your answer should be very brief. 0.98. What is the ratio of the Employment (as % of total employment) in Industry in 1998 to that in 1999?
Offer a very short reply. 1.03. What is the ratio of the Employment (as % of total employment) in Agriculture in 1998 to that in 2000?
Provide a succinct answer. 1.08. What is the ratio of the Employment (as % of total employment) of Industry in 1998 to that in 2000?
Your response must be concise. 1.07. What is the ratio of the Employment (as % of total employment) in Services in 1998 to that in 2000?
Your response must be concise. 0.95. What is the ratio of the Employment (as % of total employment) in Self-employed in 1998 to that in 2000?
Ensure brevity in your answer.  1.07. What is the ratio of the Employment (as % of total employment) in Agriculture in 1998 to that in 2001?
Make the answer very short. 1.16. What is the ratio of the Employment (as % of total employment) of Industry in 1998 to that in 2001?
Keep it short and to the point. 1.13. What is the ratio of the Employment (as % of total employment) in Services in 1998 to that in 2001?
Your response must be concise. 0.91. What is the ratio of the Employment (as % of total employment) in Self-employed in 1998 to that in 2001?
Provide a succinct answer. 1.04. What is the ratio of the Employment (as % of total employment) of Agriculture in 1999 to that in 2000?
Offer a very short reply. 1.1. What is the ratio of the Employment (as % of total employment) of Industry in 1999 to that in 2000?
Make the answer very short. 1.04. What is the ratio of the Employment (as % of total employment) in Services in 1999 to that in 2000?
Keep it short and to the point. 0.96. What is the ratio of the Employment (as % of total employment) of Self-employed in 1999 to that in 2000?
Your response must be concise. 1.1. What is the ratio of the Employment (as % of total employment) in Agriculture in 1999 to that in 2001?
Give a very brief answer. 1.18. What is the ratio of the Employment (as % of total employment) of Industry in 1999 to that in 2001?
Keep it short and to the point. 1.1. What is the ratio of the Employment (as % of total employment) of Services in 1999 to that in 2001?
Keep it short and to the point. 0.92. What is the ratio of the Employment (as % of total employment) of Self-employed in 1999 to that in 2001?
Your answer should be compact. 1.06. What is the ratio of the Employment (as % of total employment) in Agriculture in 2000 to that in 2001?
Offer a very short reply. 1.07. What is the ratio of the Employment (as % of total employment) of Industry in 2000 to that in 2001?
Offer a very short reply. 1.05. What is the difference between the highest and the second highest Employment (as % of total employment) in Industry?
Offer a very short reply. 0.1. What is the difference between the highest and the second highest Employment (as % of total employment) of Services?
Your answer should be compact. 0.7. What is the difference between the highest and the second highest Employment (as % of total employment) of Self-employed?
Ensure brevity in your answer.  1.2. What is the difference between the highest and the lowest Employment (as % of total employment) of Agriculture?
Your response must be concise. 5.6. What is the difference between the highest and the lowest Employment (as % of total employment) in Services?
Your answer should be very brief. 8. What is the difference between the highest and the lowest Employment (as % of total employment) of Self-employed?
Offer a terse response. 8.2. 